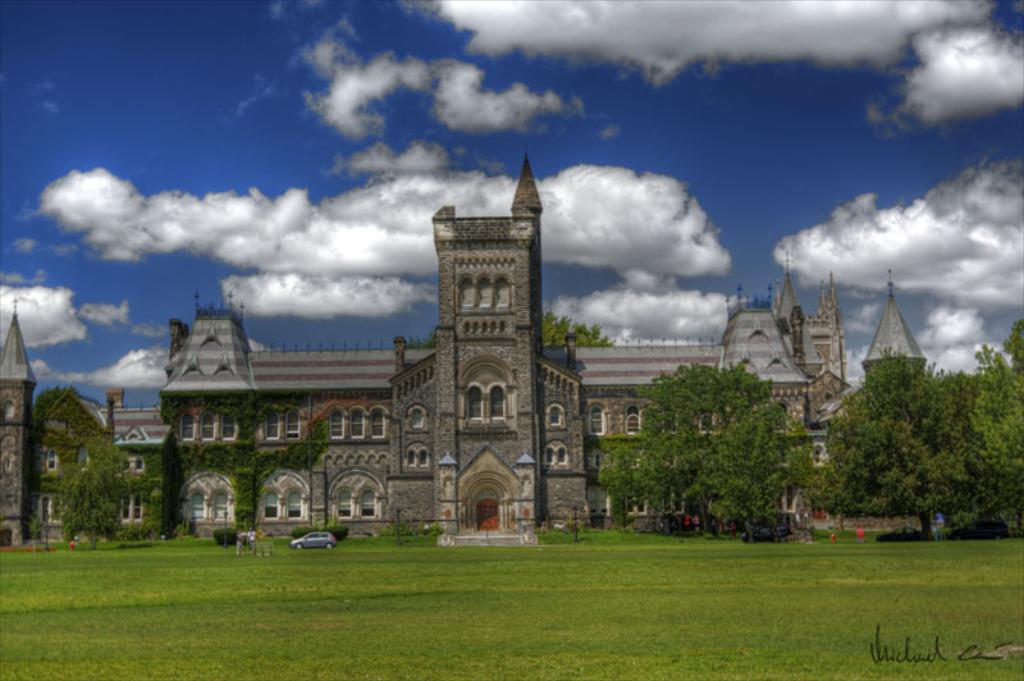In one or two sentences, can you explain what this image depicts? In this image I can see the ground which is in green color. On the ground I can see the vehicle and few people to the side. In the back I can see the house and to the side there are many trees. In the background there are clouds and the blue sky. 